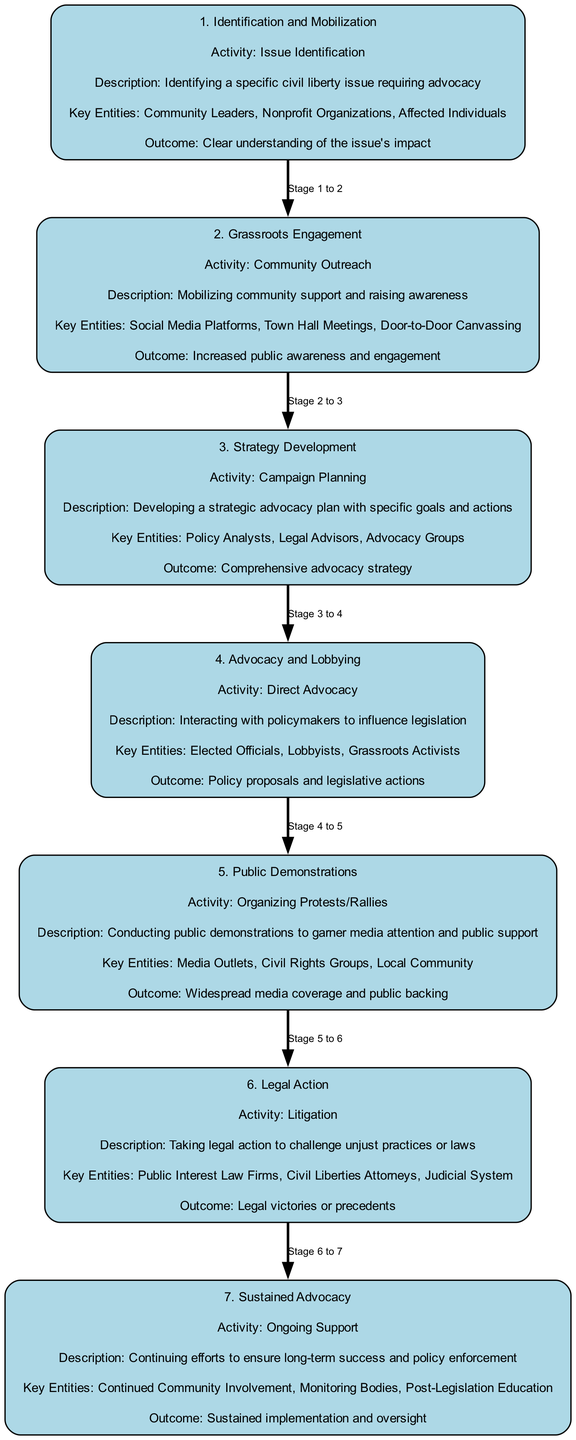What is the first stage of the clinical pathway? The diagram lists the stages in sequential order. The first stage mentioned is "1. Identification and Mobilization."
Answer: Identification and Mobilization How many key entities are involved in the "Grassroots Engagement" stage? By examining the "Grassroots Engagement" stage, I see three key entities: Social Media Platforms, Town Hall Meetings, and Door-to-Door Canvassing.
Answer: Three What is the main outcome of the "Legal Action" stage? The outcome for the "Legal Action" stage is stated as "Legal victories or precedents."
Answer: Legal victories or precedents Which stage comes directly after "Strategy Development"? The stages are arranged sequentially, thus the stage that follows "Strategy Development" (which is the third stage) is "Advocacy and Lobbying" (the fourth stage).
Answer: Advocacy and Lobbying What is the activity described in the "Public Demonstrations" stage? The activity mentioned in the "Public Demonstrations" stage is "Organizing Protests/Rallies."
Answer: Organizing Protests/Rallies Who are the key entities listed in the "Ongoing Support" stage? In the "Sustained Advocacy" stage (also known as "Ongoing Support"), the key entities mentioned are Continued Community Involvement, Monitoring Bodies, and Post-Legislation Education.
Answer: Continued Community Involvement, Monitoring Bodies, Post-Legislation Education What is the relationship between "Grassroots Engagement" and "Strategy Development"? The relationship is sequential in nature; "Grassroots Engagement" is the second stage and leads into "Strategy Development," which is the third stage in the pathway.
Answer: Sequential How many stages are included in the clinical pathway diagram? The diagram contains a total of seven stages outlined for the clinical pathway.
Answer: Seven What is the purpose of the activity in the "Identification and Mobilization" stage? The purpose of the activity in this stage, "Issue Identification," is to determine a specific civil liberty issue that requires advocacy, providing clarity on its impact.
Answer: Clear understanding of the issue's impact 